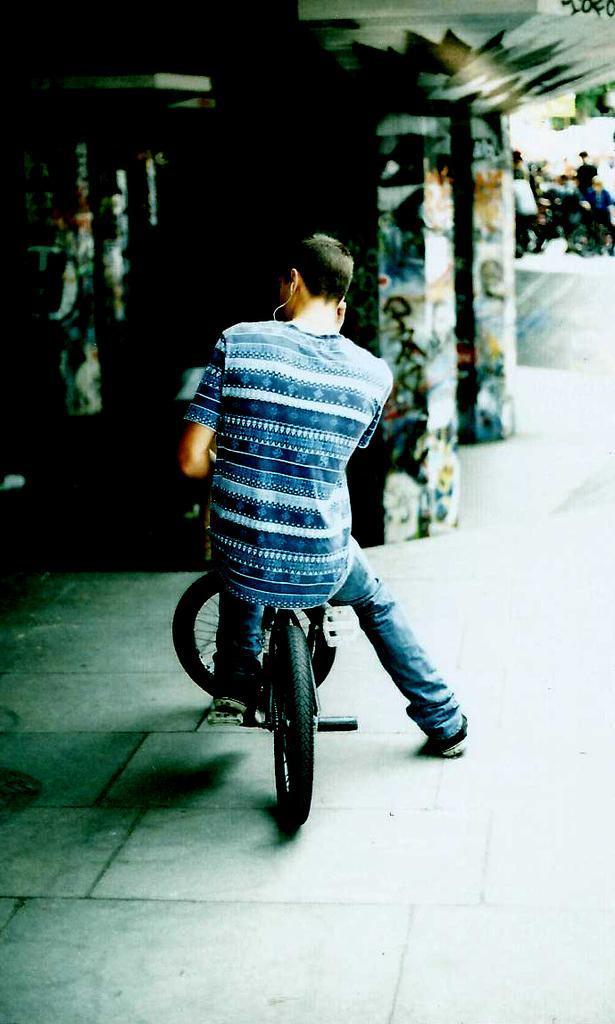Can you describe this image briefly? In the picture we can see a man sitting on a bicycle. In the background we can see a pillars and wall and some people are standing bit far to them. 